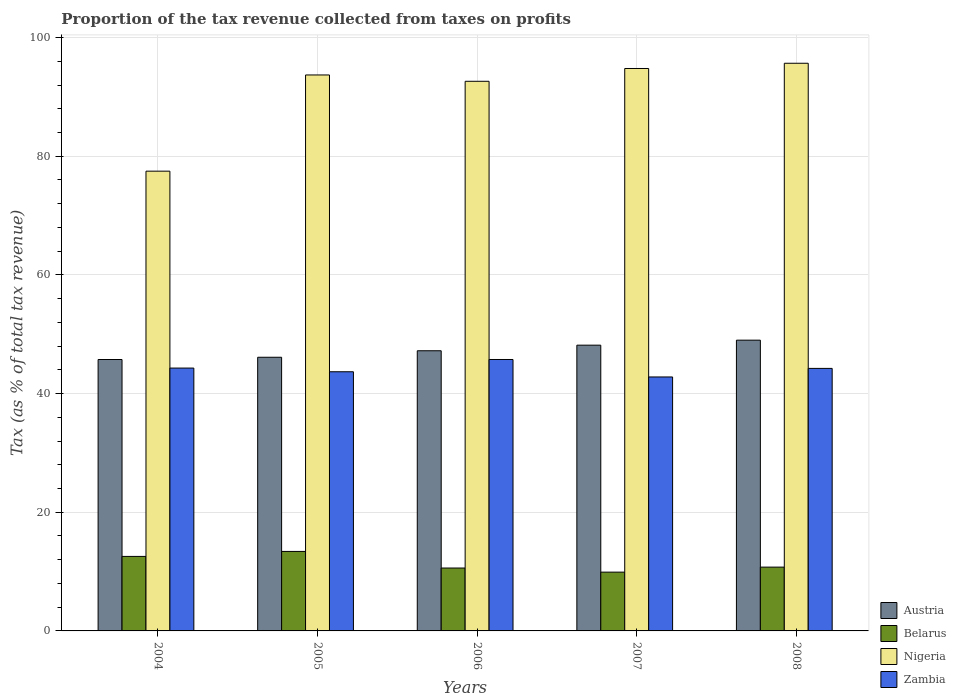How many different coloured bars are there?
Provide a succinct answer. 4. Are the number of bars on each tick of the X-axis equal?
Offer a very short reply. Yes. How many bars are there on the 5th tick from the left?
Offer a terse response. 4. In how many cases, is the number of bars for a given year not equal to the number of legend labels?
Your answer should be very brief. 0. What is the proportion of the tax revenue collected in Austria in 2006?
Provide a succinct answer. 47.22. Across all years, what is the maximum proportion of the tax revenue collected in Austria?
Your response must be concise. 49. Across all years, what is the minimum proportion of the tax revenue collected in Nigeria?
Keep it short and to the point. 77.48. What is the total proportion of the tax revenue collected in Nigeria in the graph?
Keep it short and to the point. 454.27. What is the difference between the proportion of the tax revenue collected in Nigeria in 2004 and that in 2006?
Provide a short and direct response. -15.15. What is the difference between the proportion of the tax revenue collected in Zambia in 2007 and the proportion of the tax revenue collected in Belarus in 2006?
Give a very brief answer. 32.2. What is the average proportion of the tax revenue collected in Belarus per year?
Offer a terse response. 11.44. In the year 2008, what is the difference between the proportion of the tax revenue collected in Zambia and proportion of the tax revenue collected in Nigeria?
Keep it short and to the point. -51.43. What is the ratio of the proportion of the tax revenue collected in Zambia in 2004 to that in 2005?
Ensure brevity in your answer.  1.01. What is the difference between the highest and the second highest proportion of the tax revenue collected in Austria?
Provide a succinct answer. 0.84. What is the difference between the highest and the lowest proportion of the tax revenue collected in Austria?
Ensure brevity in your answer.  3.26. In how many years, is the proportion of the tax revenue collected in Nigeria greater than the average proportion of the tax revenue collected in Nigeria taken over all years?
Offer a terse response. 4. Is the sum of the proportion of the tax revenue collected in Austria in 2006 and 2007 greater than the maximum proportion of the tax revenue collected in Nigeria across all years?
Offer a very short reply. No. Is it the case that in every year, the sum of the proportion of the tax revenue collected in Belarus and proportion of the tax revenue collected in Zambia is greater than the sum of proportion of the tax revenue collected in Austria and proportion of the tax revenue collected in Nigeria?
Your response must be concise. No. What does the 3rd bar from the left in 2008 represents?
Offer a very short reply. Nigeria. What does the 3rd bar from the right in 2006 represents?
Make the answer very short. Belarus. Is it the case that in every year, the sum of the proportion of the tax revenue collected in Belarus and proportion of the tax revenue collected in Austria is greater than the proportion of the tax revenue collected in Zambia?
Offer a terse response. Yes. How many bars are there?
Your answer should be very brief. 20. What is the difference between two consecutive major ticks on the Y-axis?
Provide a short and direct response. 20. Are the values on the major ticks of Y-axis written in scientific E-notation?
Ensure brevity in your answer.  No. How are the legend labels stacked?
Your response must be concise. Vertical. What is the title of the graph?
Provide a succinct answer. Proportion of the tax revenue collected from taxes on profits. What is the label or title of the X-axis?
Keep it short and to the point. Years. What is the label or title of the Y-axis?
Your answer should be compact. Tax (as % of total tax revenue). What is the Tax (as % of total tax revenue) of Austria in 2004?
Ensure brevity in your answer.  45.74. What is the Tax (as % of total tax revenue) of Belarus in 2004?
Provide a succinct answer. 12.56. What is the Tax (as % of total tax revenue) in Nigeria in 2004?
Keep it short and to the point. 77.48. What is the Tax (as % of total tax revenue) of Zambia in 2004?
Provide a short and direct response. 44.3. What is the Tax (as % of total tax revenue) in Austria in 2005?
Your response must be concise. 46.12. What is the Tax (as % of total tax revenue) of Belarus in 2005?
Offer a very short reply. 13.4. What is the Tax (as % of total tax revenue) in Nigeria in 2005?
Your answer should be compact. 93.7. What is the Tax (as % of total tax revenue) in Zambia in 2005?
Your answer should be very brief. 43.68. What is the Tax (as % of total tax revenue) in Austria in 2006?
Keep it short and to the point. 47.22. What is the Tax (as % of total tax revenue) in Belarus in 2006?
Provide a short and direct response. 10.6. What is the Tax (as % of total tax revenue) in Nigeria in 2006?
Give a very brief answer. 92.63. What is the Tax (as % of total tax revenue) in Zambia in 2006?
Make the answer very short. 45.74. What is the Tax (as % of total tax revenue) in Austria in 2007?
Give a very brief answer. 48.16. What is the Tax (as % of total tax revenue) of Belarus in 2007?
Give a very brief answer. 9.91. What is the Tax (as % of total tax revenue) of Nigeria in 2007?
Provide a succinct answer. 94.79. What is the Tax (as % of total tax revenue) of Zambia in 2007?
Make the answer very short. 42.8. What is the Tax (as % of total tax revenue) in Austria in 2008?
Offer a terse response. 49. What is the Tax (as % of total tax revenue) in Belarus in 2008?
Make the answer very short. 10.75. What is the Tax (as % of total tax revenue) of Nigeria in 2008?
Provide a short and direct response. 95.67. What is the Tax (as % of total tax revenue) of Zambia in 2008?
Your answer should be compact. 44.24. Across all years, what is the maximum Tax (as % of total tax revenue) of Austria?
Give a very brief answer. 49. Across all years, what is the maximum Tax (as % of total tax revenue) of Belarus?
Your answer should be very brief. 13.4. Across all years, what is the maximum Tax (as % of total tax revenue) of Nigeria?
Your answer should be compact. 95.67. Across all years, what is the maximum Tax (as % of total tax revenue) in Zambia?
Your response must be concise. 45.74. Across all years, what is the minimum Tax (as % of total tax revenue) of Austria?
Provide a short and direct response. 45.74. Across all years, what is the minimum Tax (as % of total tax revenue) of Belarus?
Your answer should be compact. 9.91. Across all years, what is the minimum Tax (as % of total tax revenue) in Nigeria?
Keep it short and to the point. 77.48. Across all years, what is the minimum Tax (as % of total tax revenue) in Zambia?
Offer a very short reply. 42.8. What is the total Tax (as % of total tax revenue) of Austria in the graph?
Provide a short and direct response. 236.24. What is the total Tax (as % of total tax revenue) in Belarus in the graph?
Offer a very short reply. 57.22. What is the total Tax (as % of total tax revenue) in Nigeria in the graph?
Offer a very short reply. 454.27. What is the total Tax (as % of total tax revenue) of Zambia in the graph?
Provide a succinct answer. 220.77. What is the difference between the Tax (as % of total tax revenue) in Austria in 2004 and that in 2005?
Keep it short and to the point. -0.38. What is the difference between the Tax (as % of total tax revenue) in Belarus in 2004 and that in 2005?
Make the answer very short. -0.84. What is the difference between the Tax (as % of total tax revenue) in Nigeria in 2004 and that in 2005?
Your answer should be very brief. -16.21. What is the difference between the Tax (as % of total tax revenue) of Zambia in 2004 and that in 2005?
Give a very brief answer. 0.62. What is the difference between the Tax (as % of total tax revenue) in Austria in 2004 and that in 2006?
Keep it short and to the point. -1.47. What is the difference between the Tax (as % of total tax revenue) of Belarus in 2004 and that in 2006?
Your answer should be very brief. 1.96. What is the difference between the Tax (as % of total tax revenue) in Nigeria in 2004 and that in 2006?
Provide a short and direct response. -15.15. What is the difference between the Tax (as % of total tax revenue) in Zambia in 2004 and that in 2006?
Your answer should be very brief. -1.44. What is the difference between the Tax (as % of total tax revenue) of Austria in 2004 and that in 2007?
Keep it short and to the point. -2.42. What is the difference between the Tax (as % of total tax revenue) of Belarus in 2004 and that in 2007?
Make the answer very short. 2.65. What is the difference between the Tax (as % of total tax revenue) in Nigeria in 2004 and that in 2007?
Ensure brevity in your answer.  -17.31. What is the difference between the Tax (as % of total tax revenue) in Zambia in 2004 and that in 2007?
Provide a short and direct response. 1.5. What is the difference between the Tax (as % of total tax revenue) in Austria in 2004 and that in 2008?
Offer a terse response. -3.26. What is the difference between the Tax (as % of total tax revenue) of Belarus in 2004 and that in 2008?
Make the answer very short. 1.8. What is the difference between the Tax (as % of total tax revenue) in Nigeria in 2004 and that in 2008?
Provide a short and direct response. -18.19. What is the difference between the Tax (as % of total tax revenue) in Zambia in 2004 and that in 2008?
Your answer should be very brief. 0.06. What is the difference between the Tax (as % of total tax revenue) in Austria in 2005 and that in 2006?
Make the answer very short. -1.1. What is the difference between the Tax (as % of total tax revenue) of Belarus in 2005 and that in 2006?
Ensure brevity in your answer.  2.8. What is the difference between the Tax (as % of total tax revenue) in Nigeria in 2005 and that in 2006?
Your response must be concise. 1.06. What is the difference between the Tax (as % of total tax revenue) of Zambia in 2005 and that in 2006?
Provide a succinct answer. -2.07. What is the difference between the Tax (as % of total tax revenue) in Austria in 2005 and that in 2007?
Offer a terse response. -2.04. What is the difference between the Tax (as % of total tax revenue) in Belarus in 2005 and that in 2007?
Your response must be concise. 3.49. What is the difference between the Tax (as % of total tax revenue) in Nigeria in 2005 and that in 2007?
Ensure brevity in your answer.  -1.09. What is the difference between the Tax (as % of total tax revenue) in Zambia in 2005 and that in 2007?
Give a very brief answer. 0.88. What is the difference between the Tax (as % of total tax revenue) in Austria in 2005 and that in 2008?
Provide a short and direct response. -2.88. What is the difference between the Tax (as % of total tax revenue) in Belarus in 2005 and that in 2008?
Give a very brief answer. 2.64. What is the difference between the Tax (as % of total tax revenue) of Nigeria in 2005 and that in 2008?
Your response must be concise. -1.97. What is the difference between the Tax (as % of total tax revenue) in Zambia in 2005 and that in 2008?
Provide a short and direct response. -0.57. What is the difference between the Tax (as % of total tax revenue) of Austria in 2006 and that in 2007?
Keep it short and to the point. -0.94. What is the difference between the Tax (as % of total tax revenue) of Belarus in 2006 and that in 2007?
Offer a terse response. 0.69. What is the difference between the Tax (as % of total tax revenue) of Nigeria in 2006 and that in 2007?
Ensure brevity in your answer.  -2.16. What is the difference between the Tax (as % of total tax revenue) in Zambia in 2006 and that in 2007?
Offer a very short reply. 2.94. What is the difference between the Tax (as % of total tax revenue) of Austria in 2006 and that in 2008?
Provide a short and direct response. -1.79. What is the difference between the Tax (as % of total tax revenue) in Belarus in 2006 and that in 2008?
Keep it short and to the point. -0.15. What is the difference between the Tax (as % of total tax revenue) of Nigeria in 2006 and that in 2008?
Give a very brief answer. -3.04. What is the difference between the Tax (as % of total tax revenue) of Zambia in 2006 and that in 2008?
Make the answer very short. 1.5. What is the difference between the Tax (as % of total tax revenue) of Austria in 2007 and that in 2008?
Offer a terse response. -0.84. What is the difference between the Tax (as % of total tax revenue) in Belarus in 2007 and that in 2008?
Your response must be concise. -0.85. What is the difference between the Tax (as % of total tax revenue) of Nigeria in 2007 and that in 2008?
Ensure brevity in your answer.  -0.88. What is the difference between the Tax (as % of total tax revenue) of Zambia in 2007 and that in 2008?
Give a very brief answer. -1.44. What is the difference between the Tax (as % of total tax revenue) in Austria in 2004 and the Tax (as % of total tax revenue) in Belarus in 2005?
Your answer should be compact. 32.34. What is the difference between the Tax (as % of total tax revenue) in Austria in 2004 and the Tax (as % of total tax revenue) in Nigeria in 2005?
Your answer should be very brief. -47.95. What is the difference between the Tax (as % of total tax revenue) of Austria in 2004 and the Tax (as % of total tax revenue) of Zambia in 2005?
Ensure brevity in your answer.  2.07. What is the difference between the Tax (as % of total tax revenue) in Belarus in 2004 and the Tax (as % of total tax revenue) in Nigeria in 2005?
Provide a succinct answer. -81.14. What is the difference between the Tax (as % of total tax revenue) in Belarus in 2004 and the Tax (as % of total tax revenue) in Zambia in 2005?
Your answer should be very brief. -31.12. What is the difference between the Tax (as % of total tax revenue) of Nigeria in 2004 and the Tax (as % of total tax revenue) of Zambia in 2005?
Keep it short and to the point. 33.81. What is the difference between the Tax (as % of total tax revenue) of Austria in 2004 and the Tax (as % of total tax revenue) of Belarus in 2006?
Your response must be concise. 35.14. What is the difference between the Tax (as % of total tax revenue) of Austria in 2004 and the Tax (as % of total tax revenue) of Nigeria in 2006?
Your answer should be very brief. -46.89. What is the difference between the Tax (as % of total tax revenue) in Austria in 2004 and the Tax (as % of total tax revenue) in Zambia in 2006?
Your answer should be very brief. -0. What is the difference between the Tax (as % of total tax revenue) in Belarus in 2004 and the Tax (as % of total tax revenue) in Nigeria in 2006?
Make the answer very short. -80.07. What is the difference between the Tax (as % of total tax revenue) in Belarus in 2004 and the Tax (as % of total tax revenue) in Zambia in 2006?
Your answer should be very brief. -33.19. What is the difference between the Tax (as % of total tax revenue) in Nigeria in 2004 and the Tax (as % of total tax revenue) in Zambia in 2006?
Provide a succinct answer. 31.74. What is the difference between the Tax (as % of total tax revenue) in Austria in 2004 and the Tax (as % of total tax revenue) in Belarus in 2007?
Provide a short and direct response. 35.84. What is the difference between the Tax (as % of total tax revenue) in Austria in 2004 and the Tax (as % of total tax revenue) in Nigeria in 2007?
Offer a terse response. -49.05. What is the difference between the Tax (as % of total tax revenue) of Austria in 2004 and the Tax (as % of total tax revenue) of Zambia in 2007?
Provide a short and direct response. 2.94. What is the difference between the Tax (as % of total tax revenue) of Belarus in 2004 and the Tax (as % of total tax revenue) of Nigeria in 2007?
Provide a short and direct response. -82.23. What is the difference between the Tax (as % of total tax revenue) in Belarus in 2004 and the Tax (as % of total tax revenue) in Zambia in 2007?
Offer a terse response. -30.24. What is the difference between the Tax (as % of total tax revenue) in Nigeria in 2004 and the Tax (as % of total tax revenue) in Zambia in 2007?
Your answer should be very brief. 34.68. What is the difference between the Tax (as % of total tax revenue) in Austria in 2004 and the Tax (as % of total tax revenue) in Belarus in 2008?
Offer a very short reply. 34.99. What is the difference between the Tax (as % of total tax revenue) in Austria in 2004 and the Tax (as % of total tax revenue) in Nigeria in 2008?
Ensure brevity in your answer.  -49.93. What is the difference between the Tax (as % of total tax revenue) in Austria in 2004 and the Tax (as % of total tax revenue) in Zambia in 2008?
Your response must be concise. 1.5. What is the difference between the Tax (as % of total tax revenue) of Belarus in 2004 and the Tax (as % of total tax revenue) of Nigeria in 2008?
Your response must be concise. -83.11. What is the difference between the Tax (as % of total tax revenue) in Belarus in 2004 and the Tax (as % of total tax revenue) in Zambia in 2008?
Ensure brevity in your answer.  -31.69. What is the difference between the Tax (as % of total tax revenue) in Nigeria in 2004 and the Tax (as % of total tax revenue) in Zambia in 2008?
Your response must be concise. 33.24. What is the difference between the Tax (as % of total tax revenue) of Austria in 2005 and the Tax (as % of total tax revenue) of Belarus in 2006?
Keep it short and to the point. 35.52. What is the difference between the Tax (as % of total tax revenue) in Austria in 2005 and the Tax (as % of total tax revenue) in Nigeria in 2006?
Keep it short and to the point. -46.51. What is the difference between the Tax (as % of total tax revenue) of Austria in 2005 and the Tax (as % of total tax revenue) of Zambia in 2006?
Your answer should be very brief. 0.38. What is the difference between the Tax (as % of total tax revenue) of Belarus in 2005 and the Tax (as % of total tax revenue) of Nigeria in 2006?
Keep it short and to the point. -79.23. What is the difference between the Tax (as % of total tax revenue) in Belarus in 2005 and the Tax (as % of total tax revenue) in Zambia in 2006?
Offer a terse response. -32.35. What is the difference between the Tax (as % of total tax revenue) of Nigeria in 2005 and the Tax (as % of total tax revenue) of Zambia in 2006?
Provide a succinct answer. 47.95. What is the difference between the Tax (as % of total tax revenue) in Austria in 2005 and the Tax (as % of total tax revenue) in Belarus in 2007?
Ensure brevity in your answer.  36.21. What is the difference between the Tax (as % of total tax revenue) of Austria in 2005 and the Tax (as % of total tax revenue) of Nigeria in 2007?
Give a very brief answer. -48.67. What is the difference between the Tax (as % of total tax revenue) in Austria in 2005 and the Tax (as % of total tax revenue) in Zambia in 2007?
Offer a terse response. 3.32. What is the difference between the Tax (as % of total tax revenue) of Belarus in 2005 and the Tax (as % of total tax revenue) of Nigeria in 2007?
Provide a short and direct response. -81.39. What is the difference between the Tax (as % of total tax revenue) of Belarus in 2005 and the Tax (as % of total tax revenue) of Zambia in 2007?
Provide a short and direct response. -29.4. What is the difference between the Tax (as % of total tax revenue) of Nigeria in 2005 and the Tax (as % of total tax revenue) of Zambia in 2007?
Keep it short and to the point. 50.9. What is the difference between the Tax (as % of total tax revenue) in Austria in 2005 and the Tax (as % of total tax revenue) in Belarus in 2008?
Your answer should be compact. 35.37. What is the difference between the Tax (as % of total tax revenue) of Austria in 2005 and the Tax (as % of total tax revenue) of Nigeria in 2008?
Offer a very short reply. -49.55. What is the difference between the Tax (as % of total tax revenue) in Austria in 2005 and the Tax (as % of total tax revenue) in Zambia in 2008?
Your response must be concise. 1.88. What is the difference between the Tax (as % of total tax revenue) in Belarus in 2005 and the Tax (as % of total tax revenue) in Nigeria in 2008?
Give a very brief answer. -82.27. What is the difference between the Tax (as % of total tax revenue) in Belarus in 2005 and the Tax (as % of total tax revenue) in Zambia in 2008?
Make the answer very short. -30.85. What is the difference between the Tax (as % of total tax revenue) of Nigeria in 2005 and the Tax (as % of total tax revenue) of Zambia in 2008?
Ensure brevity in your answer.  49.45. What is the difference between the Tax (as % of total tax revenue) in Austria in 2006 and the Tax (as % of total tax revenue) in Belarus in 2007?
Your answer should be very brief. 37.31. What is the difference between the Tax (as % of total tax revenue) of Austria in 2006 and the Tax (as % of total tax revenue) of Nigeria in 2007?
Provide a succinct answer. -47.57. What is the difference between the Tax (as % of total tax revenue) of Austria in 2006 and the Tax (as % of total tax revenue) of Zambia in 2007?
Offer a very short reply. 4.42. What is the difference between the Tax (as % of total tax revenue) of Belarus in 2006 and the Tax (as % of total tax revenue) of Nigeria in 2007?
Keep it short and to the point. -84.19. What is the difference between the Tax (as % of total tax revenue) of Belarus in 2006 and the Tax (as % of total tax revenue) of Zambia in 2007?
Your answer should be very brief. -32.2. What is the difference between the Tax (as % of total tax revenue) in Nigeria in 2006 and the Tax (as % of total tax revenue) in Zambia in 2007?
Keep it short and to the point. 49.83. What is the difference between the Tax (as % of total tax revenue) in Austria in 2006 and the Tax (as % of total tax revenue) in Belarus in 2008?
Offer a very short reply. 36.46. What is the difference between the Tax (as % of total tax revenue) of Austria in 2006 and the Tax (as % of total tax revenue) of Nigeria in 2008?
Provide a succinct answer. -48.45. What is the difference between the Tax (as % of total tax revenue) in Austria in 2006 and the Tax (as % of total tax revenue) in Zambia in 2008?
Give a very brief answer. 2.97. What is the difference between the Tax (as % of total tax revenue) of Belarus in 2006 and the Tax (as % of total tax revenue) of Nigeria in 2008?
Provide a short and direct response. -85.07. What is the difference between the Tax (as % of total tax revenue) in Belarus in 2006 and the Tax (as % of total tax revenue) in Zambia in 2008?
Your response must be concise. -33.64. What is the difference between the Tax (as % of total tax revenue) in Nigeria in 2006 and the Tax (as % of total tax revenue) in Zambia in 2008?
Make the answer very short. 48.39. What is the difference between the Tax (as % of total tax revenue) of Austria in 2007 and the Tax (as % of total tax revenue) of Belarus in 2008?
Your answer should be compact. 37.41. What is the difference between the Tax (as % of total tax revenue) of Austria in 2007 and the Tax (as % of total tax revenue) of Nigeria in 2008?
Make the answer very short. -47.51. What is the difference between the Tax (as % of total tax revenue) of Austria in 2007 and the Tax (as % of total tax revenue) of Zambia in 2008?
Provide a succinct answer. 3.92. What is the difference between the Tax (as % of total tax revenue) of Belarus in 2007 and the Tax (as % of total tax revenue) of Nigeria in 2008?
Keep it short and to the point. -85.76. What is the difference between the Tax (as % of total tax revenue) in Belarus in 2007 and the Tax (as % of total tax revenue) in Zambia in 2008?
Offer a terse response. -34.34. What is the difference between the Tax (as % of total tax revenue) of Nigeria in 2007 and the Tax (as % of total tax revenue) of Zambia in 2008?
Give a very brief answer. 50.55. What is the average Tax (as % of total tax revenue) of Austria per year?
Give a very brief answer. 47.25. What is the average Tax (as % of total tax revenue) in Belarus per year?
Your response must be concise. 11.44. What is the average Tax (as % of total tax revenue) of Nigeria per year?
Make the answer very short. 90.85. What is the average Tax (as % of total tax revenue) in Zambia per year?
Your answer should be very brief. 44.15. In the year 2004, what is the difference between the Tax (as % of total tax revenue) in Austria and Tax (as % of total tax revenue) in Belarus?
Make the answer very short. 33.18. In the year 2004, what is the difference between the Tax (as % of total tax revenue) of Austria and Tax (as % of total tax revenue) of Nigeria?
Your answer should be very brief. -31.74. In the year 2004, what is the difference between the Tax (as % of total tax revenue) of Austria and Tax (as % of total tax revenue) of Zambia?
Provide a succinct answer. 1.44. In the year 2004, what is the difference between the Tax (as % of total tax revenue) of Belarus and Tax (as % of total tax revenue) of Nigeria?
Your response must be concise. -64.93. In the year 2004, what is the difference between the Tax (as % of total tax revenue) in Belarus and Tax (as % of total tax revenue) in Zambia?
Provide a short and direct response. -31.74. In the year 2004, what is the difference between the Tax (as % of total tax revenue) in Nigeria and Tax (as % of total tax revenue) in Zambia?
Your response must be concise. 33.18. In the year 2005, what is the difference between the Tax (as % of total tax revenue) of Austria and Tax (as % of total tax revenue) of Belarus?
Provide a short and direct response. 32.72. In the year 2005, what is the difference between the Tax (as % of total tax revenue) in Austria and Tax (as % of total tax revenue) in Nigeria?
Keep it short and to the point. -47.58. In the year 2005, what is the difference between the Tax (as % of total tax revenue) in Austria and Tax (as % of total tax revenue) in Zambia?
Offer a very short reply. 2.44. In the year 2005, what is the difference between the Tax (as % of total tax revenue) in Belarus and Tax (as % of total tax revenue) in Nigeria?
Keep it short and to the point. -80.3. In the year 2005, what is the difference between the Tax (as % of total tax revenue) in Belarus and Tax (as % of total tax revenue) in Zambia?
Make the answer very short. -30.28. In the year 2005, what is the difference between the Tax (as % of total tax revenue) of Nigeria and Tax (as % of total tax revenue) of Zambia?
Ensure brevity in your answer.  50.02. In the year 2006, what is the difference between the Tax (as % of total tax revenue) in Austria and Tax (as % of total tax revenue) in Belarus?
Provide a succinct answer. 36.62. In the year 2006, what is the difference between the Tax (as % of total tax revenue) of Austria and Tax (as % of total tax revenue) of Nigeria?
Ensure brevity in your answer.  -45.42. In the year 2006, what is the difference between the Tax (as % of total tax revenue) in Austria and Tax (as % of total tax revenue) in Zambia?
Give a very brief answer. 1.47. In the year 2006, what is the difference between the Tax (as % of total tax revenue) in Belarus and Tax (as % of total tax revenue) in Nigeria?
Keep it short and to the point. -82.03. In the year 2006, what is the difference between the Tax (as % of total tax revenue) of Belarus and Tax (as % of total tax revenue) of Zambia?
Your answer should be very brief. -35.14. In the year 2006, what is the difference between the Tax (as % of total tax revenue) of Nigeria and Tax (as % of total tax revenue) of Zambia?
Provide a short and direct response. 46.89. In the year 2007, what is the difference between the Tax (as % of total tax revenue) in Austria and Tax (as % of total tax revenue) in Belarus?
Provide a short and direct response. 38.25. In the year 2007, what is the difference between the Tax (as % of total tax revenue) of Austria and Tax (as % of total tax revenue) of Nigeria?
Ensure brevity in your answer.  -46.63. In the year 2007, what is the difference between the Tax (as % of total tax revenue) in Austria and Tax (as % of total tax revenue) in Zambia?
Give a very brief answer. 5.36. In the year 2007, what is the difference between the Tax (as % of total tax revenue) in Belarus and Tax (as % of total tax revenue) in Nigeria?
Your response must be concise. -84.88. In the year 2007, what is the difference between the Tax (as % of total tax revenue) of Belarus and Tax (as % of total tax revenue) of Zambia?
Offer a very short reply. -32.89. In the year 2007, what is the difference between the Tax (as % of total tax revenue) in Nigeria and Tax (as % of total tax revenue) in Zambia?
Your answer should be compact. 51.99. In the year 2008, what is the difference between the Tax (as % of total tax revenue) in Austria and Tax (as % of total tax revenue) in Belarus?
Keep it short and to the point. 38.25. In the year 2008, what is the difference between the Tax (as % of total tax revenue) in Austria and Tax (as % of total tax revenue) in Nigeria?
Your answer should be compact. -46.67. In the year 2008, what is the difference between the Tax (as % of total tax revenue) in Austria and Tax (as % of total tax revenue) in Zambia?
Your response must be concise. 4.76. In the year 2008, what is the difference between the Tax (as % of total tax revenue) of Belarus and Tax (as % of total tax revenue) of Nigeria?
Offer a very short reply. -84.92. In the year 2008, what is the difference between the Tax (as % of total tax revenue) in Belarus and Tax (as % of total tax revenue) in Zambia?
Make the answer very short. -33.49. In the year 2008, what is the difference between the Tax (as % of total tax revenue) of Nigeria and Tax (as % of total tax revenue) of Zambia?
Keep it short and to the point. 51.43. What is the ratio of the Tax (as % of total tax revenue) in Belarus in 2004 to that in 2005?
Your answer should be compact. 0.94. What is the ratio of the Tax (as % of total tax revenue) of Nigeria in 2004 to that in 2005?
Your answer should be very brief. 0.83. What is the ratio of the Tax (as % of total tax revenue) in Zambia in 2004 to that in 2005?
Offer a terse response. 1.01. What is the ratio of the Tax (as % of total tax revenue) of Austria in 2004 to that in 2006?
Your answer should be very brief. 0.97. What is the ratio of the Tax (as % of total tax revenue) of Belarus in 2004 to that in 2006?
Provide a short and direct response. 1.18. What is the ratio of the Tax (as % of total tax revenue) of Nigeria in 2004 to that in 2006?
Your answer should be compact. 0.84. What is the ratio of the Tax (as % of total tax revenue) in Zambia in 2004 to that in 2006?
Your answer should be very brief. 0.97. What is the ratio of the Tax (as % of total tax revenue) of Austria in 2004 to that in 2007?
Your answer should be very brief. 0.95. What is the ratio of the Tax (as % of total tax revenue) of Belarus in 2004 to that in 2007?
Keep it short and to the point. 1.27. What is the ratio of the Tax (as % of total tax revenue) in Nigeria in 2004 to that in 2007?
Make the answer very short. 0.82. What is the ratio of the Tax (as % of total tax revenue) of Zambia in 2004 to that in 2007?
Provide a succinct answer. 1.03. What is the ratio of the Tax (as % of total tax revenue) of Austria in 2004 to that in 2008?
Give a very brief answer. 0.93. What is the ratio of the Tax (as % of total tax revenue) in Belarus in 2004 to that in 2008?
Keep it short and to the point. 1.17. What is the ratio of the Tax (as % of total tax revenue) of Nigeria in 2004 to that in 2008?
Offer a terse response. 0.81. What is the ratio of the Tax (as % of total tax revenue) of Zambia in 2004 to that in 2008?
Provide a succinct answer. 1. What is the ratio of the Tax (as % of total tax revenue) of Austria in 2005 to that in 2006?
Provide a short and direct response. 0.98. What is the ratio of the Tax (as % of total tax revenue) in Belarus in 2005 to that in 2006?
Offer a terse response. 1.26. What is the ratio of the Tax (as % of total tax revenue) of Nigeria in 2005 to that in 2006?
Provide a succinct answer. 1.01. What is the ratio of the Tax (as % of total tax revenue) in Zambia in 2005 to that in 2006?
Ensure brevity in your answer.  0.95. What is the ratio of the Tax (as % of total tax revenue) in Austria in 2005 to that in 2007?
Provide a short and direct response. 0.96. What is the ratio of the Tax (as % of total tax revenue) of Belarus in 2005 to that in 2007?
Offer a very short reply. 1.35. What is the ratio of the Tax (as % of total tax revenue) in Zambia in 2005 to that in 2007?
Ensure brevity in your answer.  1.02. What is the ratio of the Tax (as % of total tax revenue) of Austria in 2005 to that in 2008?
Provide a succinct answer. 0.94. What is the ratio of the Tax (as % of total tax revenue) in Belarus in 2005 to that in 2008?
Your answer should be compact. 1.25. What is the ratio of the Tax (as % of total tax revenue) in Nigeria in 2005 to that in 2008?
Your response must be concise. 0.98. What is the ratio of the Tax (as % of total tax revenue) in Zambia in 2005 to that in 2008?
Ensure brevity in your answer.  0.99. What is the ratio of the Tax (as % of total tax revenue) of Austria in 2006 to that in 2007?
Your response must be concise. 0.98. What is the ratio of the Tax (as % of total tax revenue) in Belarus in 2006 to that in 2007?
Provide a short and direct response. 1.07. What is the ratio of the Tax (as % of total tax revenue) of Nigeria in 2006 to that in 2007?
Your answer should be very brief. 0.98. What is the ratio of the Tax (as % of total tax revenue) of Zambia in 2006 to that in 2007?
Your answer should be very brief. 1.07. What is the ratio of the Tax (as % of total tax revenue) in Austria in 2006 to that in 2008?
Make the answer very short. 0.96. What is the ratio of the Tax (as % of total tax revenue) in Belarus in 2006 to that in 2008?
Keep it short and to the point. 0.99. What is the ratio of the Tax (as % of total tax revenue) of Nigeria in 2006 to that in 2008?
Your answer should be very brief. 0.97. What is the ratio of the Tax (as % of total tax revenue) in Zambia in 2006 to that in 2008?
Your answer should be compact. 1.03. What is the ratio of the Tax (as % of total tax revenue) of Austria in 2007 to that in 2008?
Your answer should be very brief. 0.98. What is the ratio of the Tax (as % of total tax revenue) of Belarus in 2007 to that in 2008?
Provide a succinct answer. 0.92. What is the ratio of the Tax (as % of total tax revenue) in Nigeria in 2007 to that in 2008?
Provide a short and direct response. 0.99. What is the ratio of the Tax (as % of total tax revenue) in Zambia in 2007 to that in 2008?
Provide a short and direct response. 0.97. What is the difference between the highest and the second highest Tax (as % of total tax revenue) in Austria?
Give a very brief answer. 0.84. What is the difference between the highest and the second highest Tax (as % of total tax revenue) of Belarus?
Offer a very short reply. 0.84. What is the difference between the highest and the second highest Tax (as % of total tax revenue) of Nigeria?
Keep it short and to the point. 0.88. What is the difference between the highest and the second highest Tax (as % of total tax revenue) of Zambia?
Your answer should be very brief. 1.44. What is the difference between the highest and the lowest Tax (as % of total tax revenue) in Austria?
Make the answer very short. 3.26. What is the difference between the highest and the lowest Tax (as % of total tax revenue) in Belarus?
Offer a very short reply. 3.49. What is the difference between the highest and the lowest Tax (as % of total tax revenue) in Nigeria?
Ensure brevity in your answer.  18.19. What is the difference between the highest and the lowest Tax (as % of total tax revenue) in Zambia?
Your response must be concise. 2.94. 